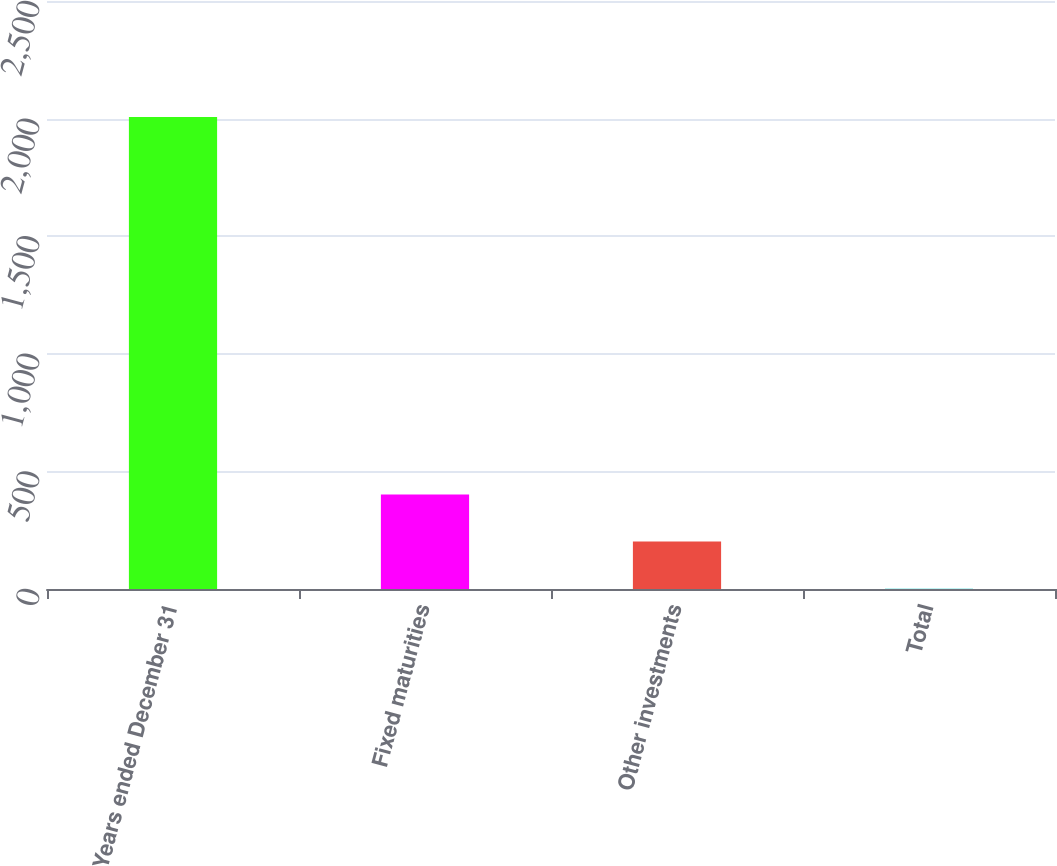Convert chart to OTSL. <chart><loc_0><loc_0><loc_500><loc_500><bar_chart><fcel>Years ended December 31<fcel>Fixed maturities<fcel>Other investments<fcel>Total<nl><fcel>2007<fcel>402.2<fcel>201.6<fcel>1<nl></chart> 